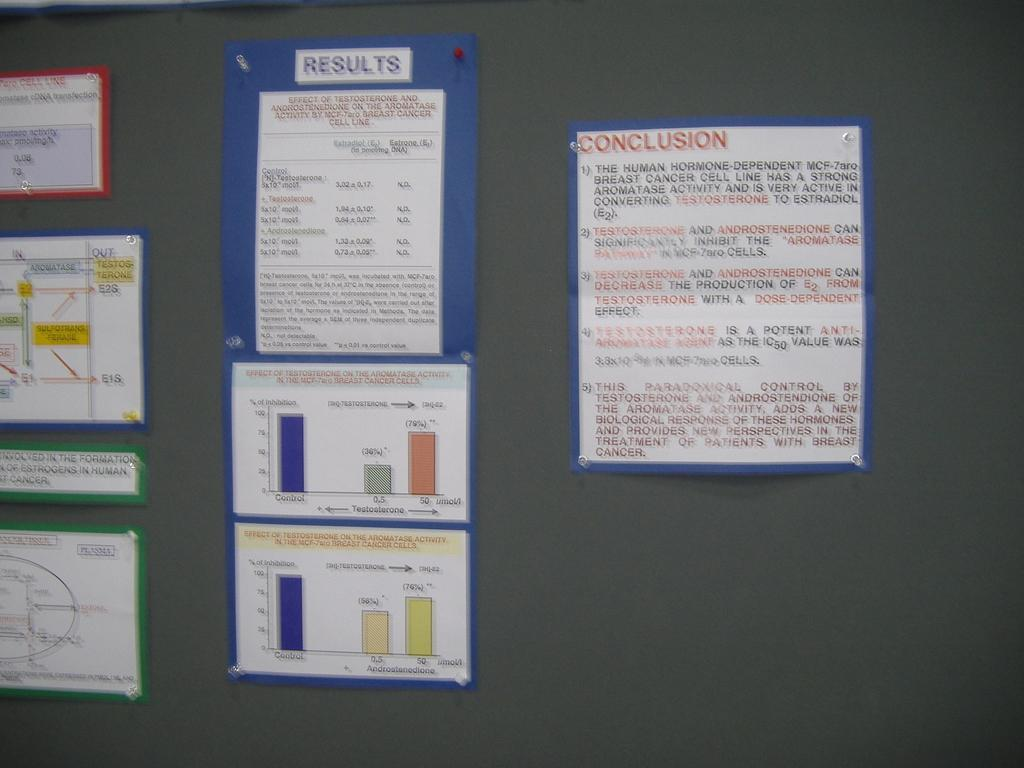What is the main subject of the image? The main subject of the image is a notice board. What can be seen on the notice board? There are notes on the notice board. What type of force is being applied to the notes on the notice board? There is no indication of any force being applied to the notes on the notice board in the image. 